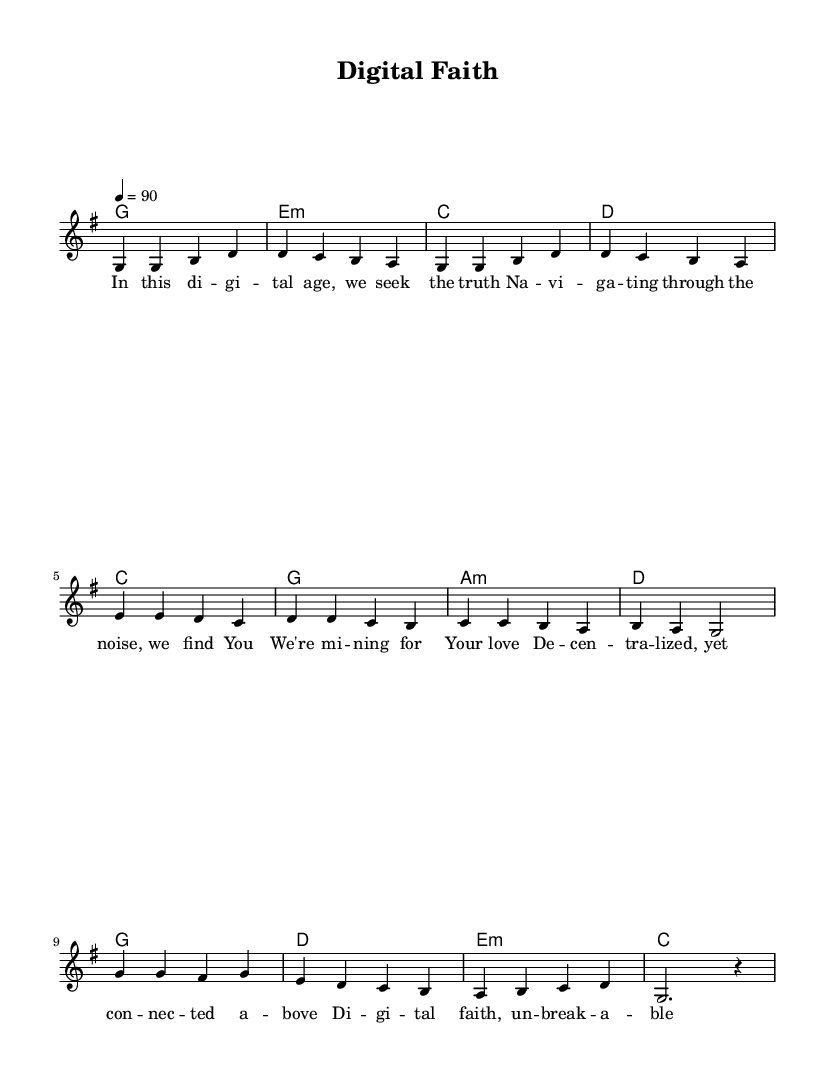What is the key signature of this music? The key signature is labeled at the beginning of the staff. It shows one sharp in the key signature, indicating the key of G major.
Answer: G major What is the time signature of this music? The time signature appears at the beginning of the staff following the key signature. It is written as "4/4", indicating four beats per measure.
Answer: 4/4 What is the tempo marking for this piece? The tempo marking is indicated at the beginning of the score, shown as "4 = 90", which means 90 beats per minute.
Answer: 90 How many measures are in the verse section? The verse section consists of four lines, each with four measures. Counting the measures in each line gives a total of 16 measures for the verse.
Answer: 16 Which chord follows the first line of the chorus? By looking at the chord progression above the melody, the chord after the first line of the chorus is a "d" chord, which is played during the lyrics of “e d c b”.
Answer: d What is the last lyric line of the verse? The last lyric line appears at the end of the verse section and contains the text: "Your grace flows through e -- very do -- main."
Answer: Your grace flows through e -- very do -- main What musical form does the song structure primarily follow? Analyzing the sections provided in the code, the song structure follows a verse-pre-chorus-chorus pattern, typically common in worship songs for a cohesive flow.
Answer: Verse-Pre-Chorus-Chorus 